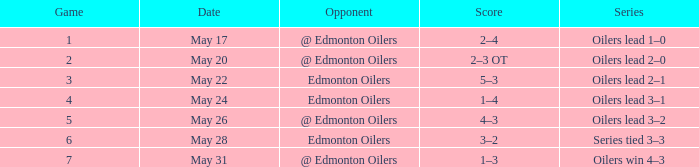Opponent of edmonton oilers, and a Game of 3 is what series? Oilers lead 2–1. 